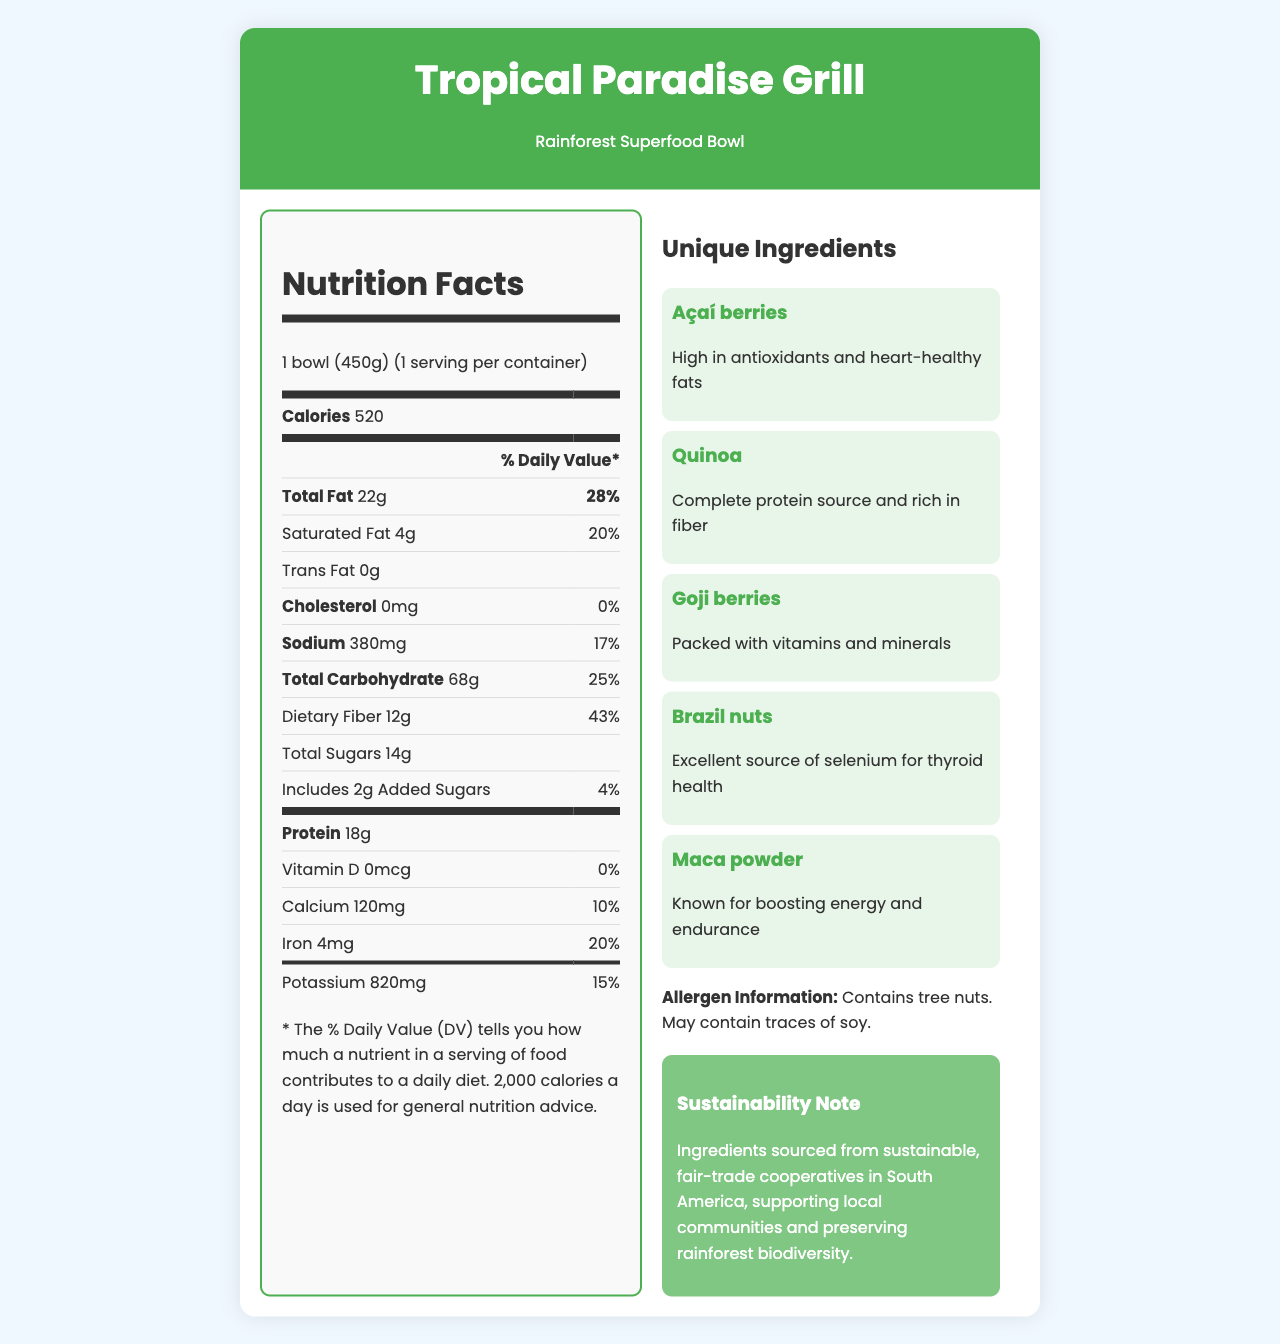what is the serving size of the Rainforest Superfood Bowl? The serving size is clearly stated under the "Nutrition Facts" section as "1 bowl (450g)".
Answer: 1 bowl (450g) how many calories are in one serving of the Rainforest Superfood Bowl? The number of calories is mentioned in the "Nutrition Facts" section as 520.
Answer: 520 calories how much dietary fiber does the dish provide? The amount of dietary fiber is listed in the "Total Carbohydrate" section as 12g.
Answer: 12g what is the daily value percentage of calcium in the Rainforest Superfood Bowl? The daily value percentage of calcium is listed in the nutritional information table as 10%.
Answer: 10% does the dish contain any trans fat? The amount of trans fat listed in the nutritional information is 0g.
Answer: No what are the unique ingredients in the Rainforest Superfood Bowl? A. Chia seeds B. Quinoa C. Açaí berries D. Almonds E. Goji berries The unique ingredients listed include Quinoa, Açaí berries, and Goji berries. Chia seeds and almonds are not listed.
Answer: B, C, E which ingredient is known for boosting energy and endurance? A. Açaí berries B. Quinoa C. Goji berries D. Maca powder The Maca powder is noted for boosting energy and endurance.
Answer: D what is the sustainability note mentioned in the document? The sustainability note specifies that ingredients are sourced from sustainable, fair-trade cooperatives in South America.
Answer: Ingredients sourced from sustainable, fair-trade cooperatives in South America, supporting local communities and preserving rainforest biodiversity is there any cholesterol in the dish? The amount of cholesterol listed in the "Nutrition Facts" section is 0mg, which means there is no cholesterol in the dish.
Answer: No what are the health benefits of Brazil nuts mentioned in the document? The document mentions that Brazil nuts are an excellent source of selenium, which is beneficial for thyroid health.
Answer: Excellent source of selenium for thyroid health does the Rainforest Superfood Bowl contain any allergens? The document notes that the dish contains tree nuts and may contain traces of soy as allergen information.
Answer: Yes summarize the main idea of the document The document focuses on the nutritional details and unique superfoods of the Rainforest Superfood Bowl and adds context about health benefits and sustainability.
Answer: The document provides nutritional information, unique ingredients, and health benefits for the Rainforest Superfood Bowl from Tropical Paradise Grill. It highlights its exotic ingredients with various health benefits, offers allergen information, and emphasizes sustainability through the use of fair-trade ingredients. which ingredient is high in antioxidants and heart-healthy fats? Açaí berries are mentioned as being high in antioxidants and heart-healthy fats.
Answer: Açaí berries how much protein is in the Rainforest Superfood Bowl? The nutritional information lists the protein content as 18g.
Answer: 18g what is the promotional description of the Rainforest Superfood Bowl? The promotional description emphasizes the vibrant flavors, nutritional power, and suitability for health-conscious travelers.
Answer: Experience the vibrant flavors and nutritional power of the Amazon rainforest with our signature Rainforest Superfood Bowl. This colorful dish combines exotic superfoods to energize your day and transport you to a tropical paradise. Perfect for health-conscious travelers looking to indulge in local flavors while maintaining their wellness routines. which ingredient is a complete protein source and rich in fiber? The document mentions that quinoa is a complete protein source and rich in fiber.
Answer: Quinoa Can I determine how much Vitamin C is in the dish? The document does not provide any information about the Vitamin C content in the dish.
Answer: Cannot be determined 